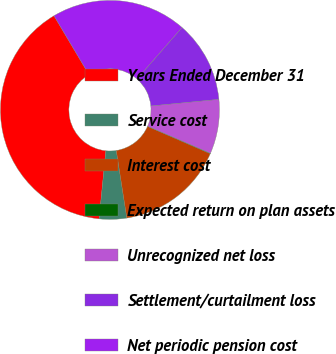Convert chart to OTSL. <chart><loc_0><loc_0><loc_500><loc_500><pie_chart><fcel>Years Ended December 31<fcel>Service cost<fcel>Interest cost<fcel>Expected return on plan assets<fcel>Unrecognized net loss<fcel>Settlement/curtailment loss<fcel>Net periodic pension cost<nl><fcel>39.89%<fcel>4.04%<fcel>15.99%<fcel>0.06%<fcel>8.03%<fcel>12.01%<fcel>19.98%<nl></chart> 